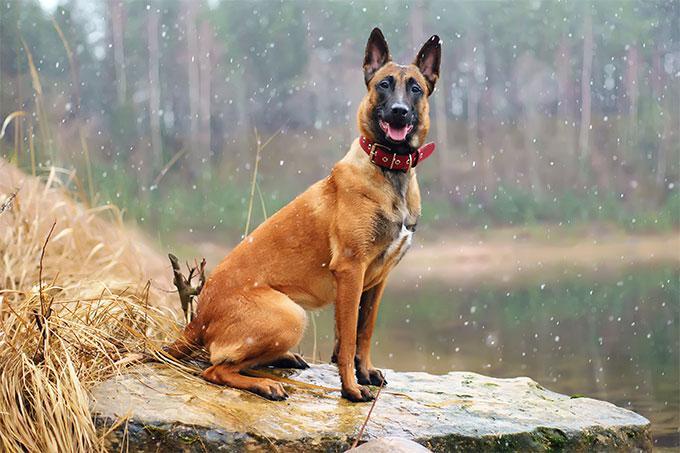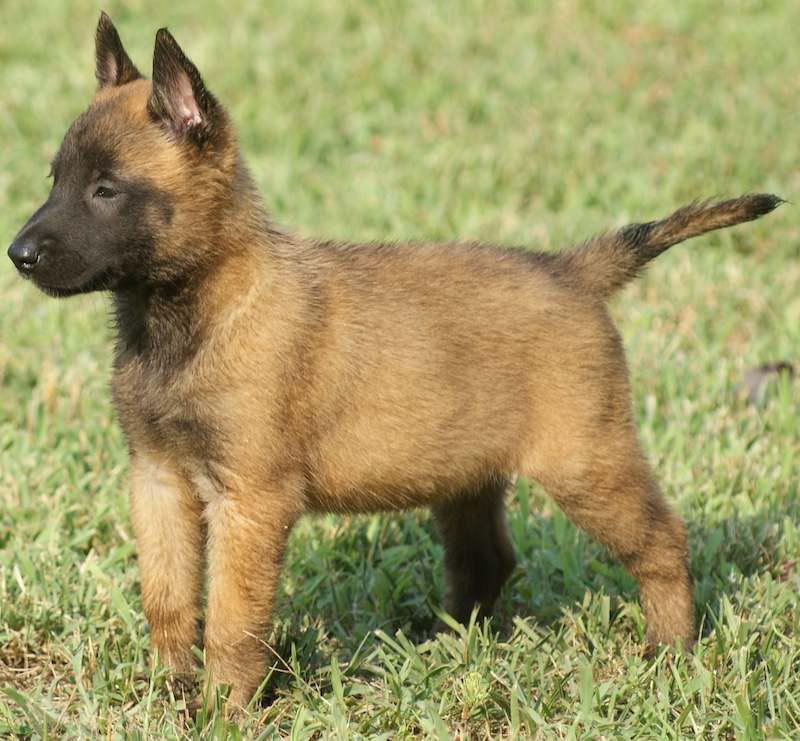The first image is the image on the left, the second image is the image on the right. Considering the images on both sides, is "One of the dogs is carrying a toy in it's mouth." valid? Answer yes or no. No. 